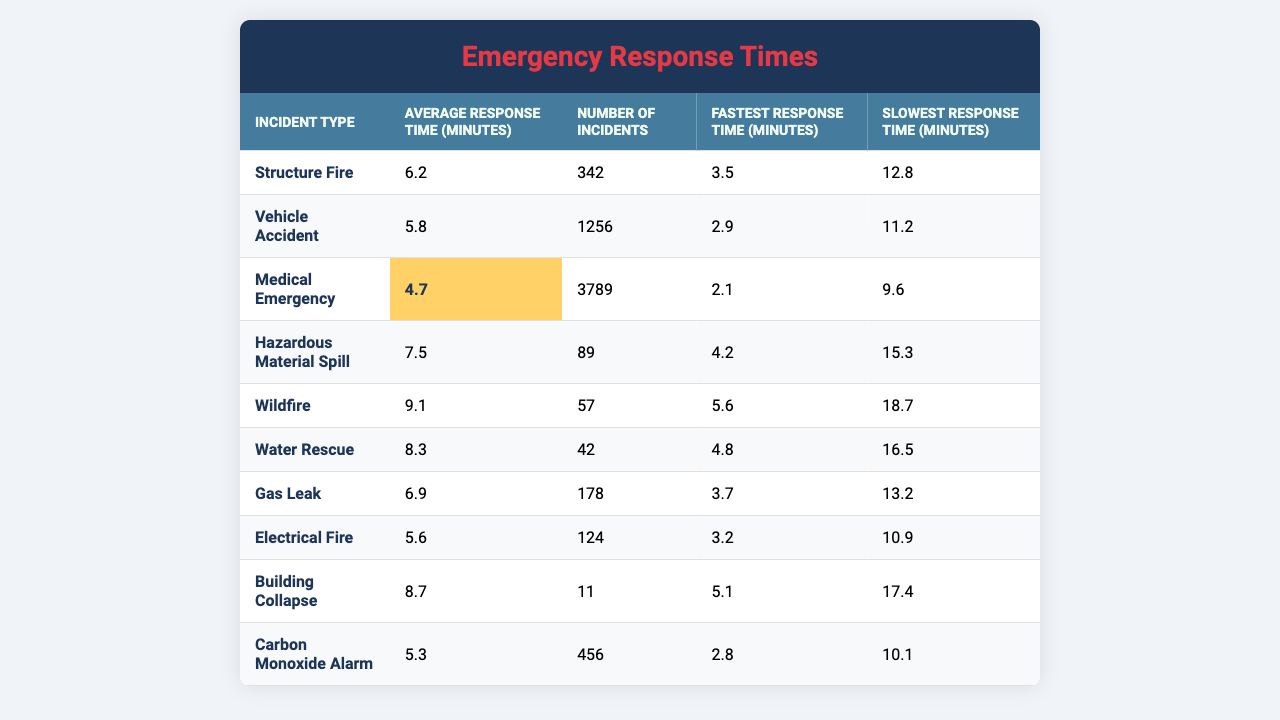What is the average response time for a medical emergency? The table shows that the average response time for a medical emergency is listed directly under the "Average Response Time (minutes)" column for that incident type.
Answer: 4.7 Which incident type has the fastest recorded response time? The "Fastest Response Time (minutes)" column shows the fastest times for each incident. Reviewing the values, the medical emergency has the lowest fastest response time at 2.1 minutes.
Answer: Medical Emergency How many vehicle accidents were reported over the past year? The number of incidents for vehicle accidents is listed in the "Number of Incidents" column directly across from the vehicle accident row. It shows a total of 1256 incidents.
Answer: 1256 What is the difference between the average response times of structure fires and wildfires? The average response time for structure fires is 6.2 minutes and for wildfires, it is 9.1 minutes. The difference is calculated as 9.1 - 6.2 = 2.9 minutes.
Answer: 2.9 Is the average response time for hazardous material spills higher than for gas leaks? The average response time for hazardous material spills is 7.5 minutes, and for gas leaks, it is 6.9 minutes. Since 7.5 is greater than 6.9, the statement is true.
Answer: Yes What is the total number of incidents recorded for all types combined? To find the total, you sum the "Number of Incidents" values for all incident types: 342 + 1256 + 3789 + 89 + 57 + 42 + 178 + 124 + 11 + 456 = 6424.
Answer: 6424 Which incident type had the slowest response time recorded? Reviewing the "Slowest Response Time (minutes)" column, the wildfires have the highest slowest response time at 18.7 minutes.
Answer: Wildfire What is the average response time across all incident types? To find the average, sum all average response times (6.2 + 5.8 + 4.7 + 7.5 + 9.1 + 8.3 + 6.9 + 5.6 + 8.7 + 5.3 = 58.2) and divide by the number of incident types (10). Thus, 58.2 / 10 = 5.82 minutes.
Answer: 5.82 